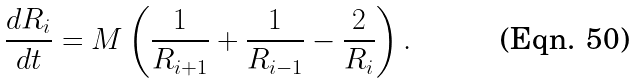Convert formula to latex. <formula><loc_0><loc_0><loc_500><loc_500>\frac { d R _ { i } } { d t } = M \left ( \frac { 1 } { R _ { i + 1 } } + \frac { 1 } { R _ { i - 1 } } - \frac { 2 } { R _ { i } } \right ) .</formula> 